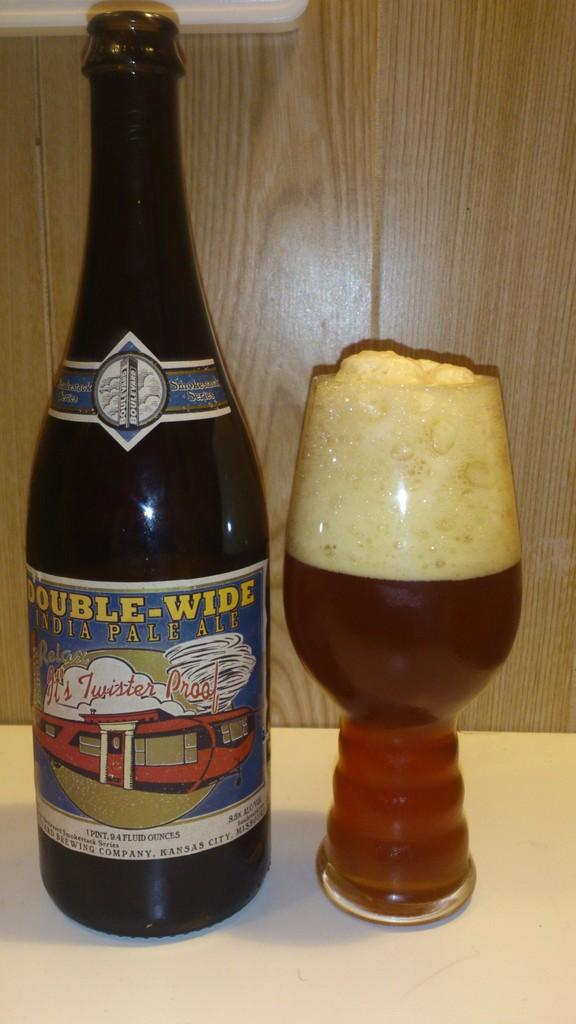<image>
Present a compact description of the photo's key features. A double wide bottle sits next to a filled glass 